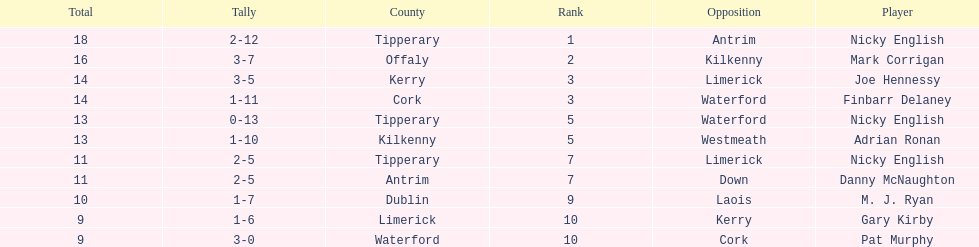Who was the top ranked player in a single game? Nicky English. 